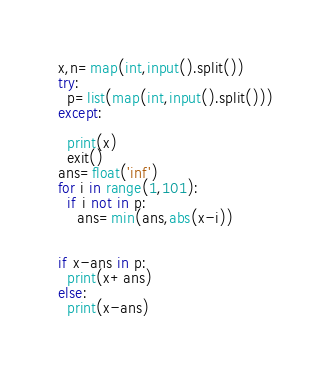<code> <loc_0><loc_0><loc_500><loc_500><_Python_>x,n=map(int,input().split())
try:
  p=list(map(int,input().split()))
except:
  
  print(x)
  exit()
ans=float('inf')
for i in range(1,101):
  if i not in p:
    ans=min(ans,abs(x-i))
    
    
if x-ans in p:
  print(x+ans)
else:
  print(x-ans)</code> 